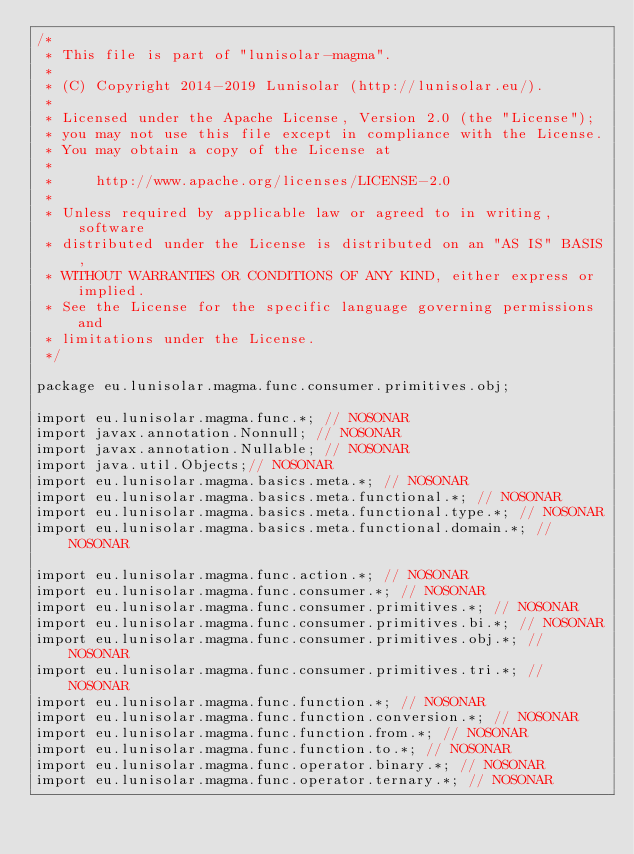<code> <loc_0><loc_0><loc_500><loc_500><_Java_>/*
 * This file is part of "lunisolar-magma".
 *
 * (C) Copyright 2014-2019 Lunisolar (http://lunisolar.eu/).
 *
 * Licensed under the Apache License, Version 2.0 (the "License");
 * you may not use this file except in compliance with the License.
 * You may obtain a copy of the License at
 *
 *     http://www.apache.org/licenses/LICENSE-2.0
 *
 * Unless required by applicable law or agreed to in writing, software
 * distributed under the License is distributed on an "AS IS" BASIS,
 * WITHOUT WARRANTIES OR CONDITIONS OF ANY KIND, either express or implied.
 * See the License for the specific language governing permissions and
 * limitations under the License.
 */

package eu.lunisolar.magma.func.consumer.primitives.obj;

import eu.lunisolar.magma.func.*; // NOSONAR
import javax.annotation.Nonnull; // NOSONAR
import javax.annotation.Nullable; // NOSONAR
import java.util.Objects;// NOSONAR
import eu.lunisolar.magma.basics.meta.*; // NOSONAR
import eu.lunisolar.magma.basics.meta.functional.*; // NOSONAR
import eu.lunisolar.magma.basics.meta.functional.type.*; // NOSONAR
import eu.lunisolar.magma.basics.meta.functional.domain.*; // NOSONAR

import eu.lunisolar.magma.func.action.*; // NOSONAR
import eu.lunisolar.magma.func.consumer.*; // NOSONAR
import eu.lunisolar.magma.func.consumer.primitives.*; // NOSONAR
import eu.lunisolar.magma.func.consumer.primitives.bi.*; // NOSONAR
import eu.lunisolar.magma.func.consumer.primitives.obj.*; // NOSONAR
import eu.lunisolar.magma.func.consumer.primitives.tri.*; // NOSONAR
import eu.lunisolar.magma.func.function.*; // NOSONAR
import eu.lunisolar.magma.func.function.conversion.*; // NOSONAR
import eu.lunisolar.magma.func.function.from.*; // NOSONAR
import eu.lunisolar.magma.func.function.to.*; // NOSONAR
import eu.lunisolar.magma.func.operator.binary.*; // NOSONAR
import eu.lunisolar.magma.func.operator.ternary.*; // NOSONAR</code> 